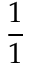<formula> <loc_0><loc_0><loc_500><loc_500>\frac { 1 } { 1 }</formula> 